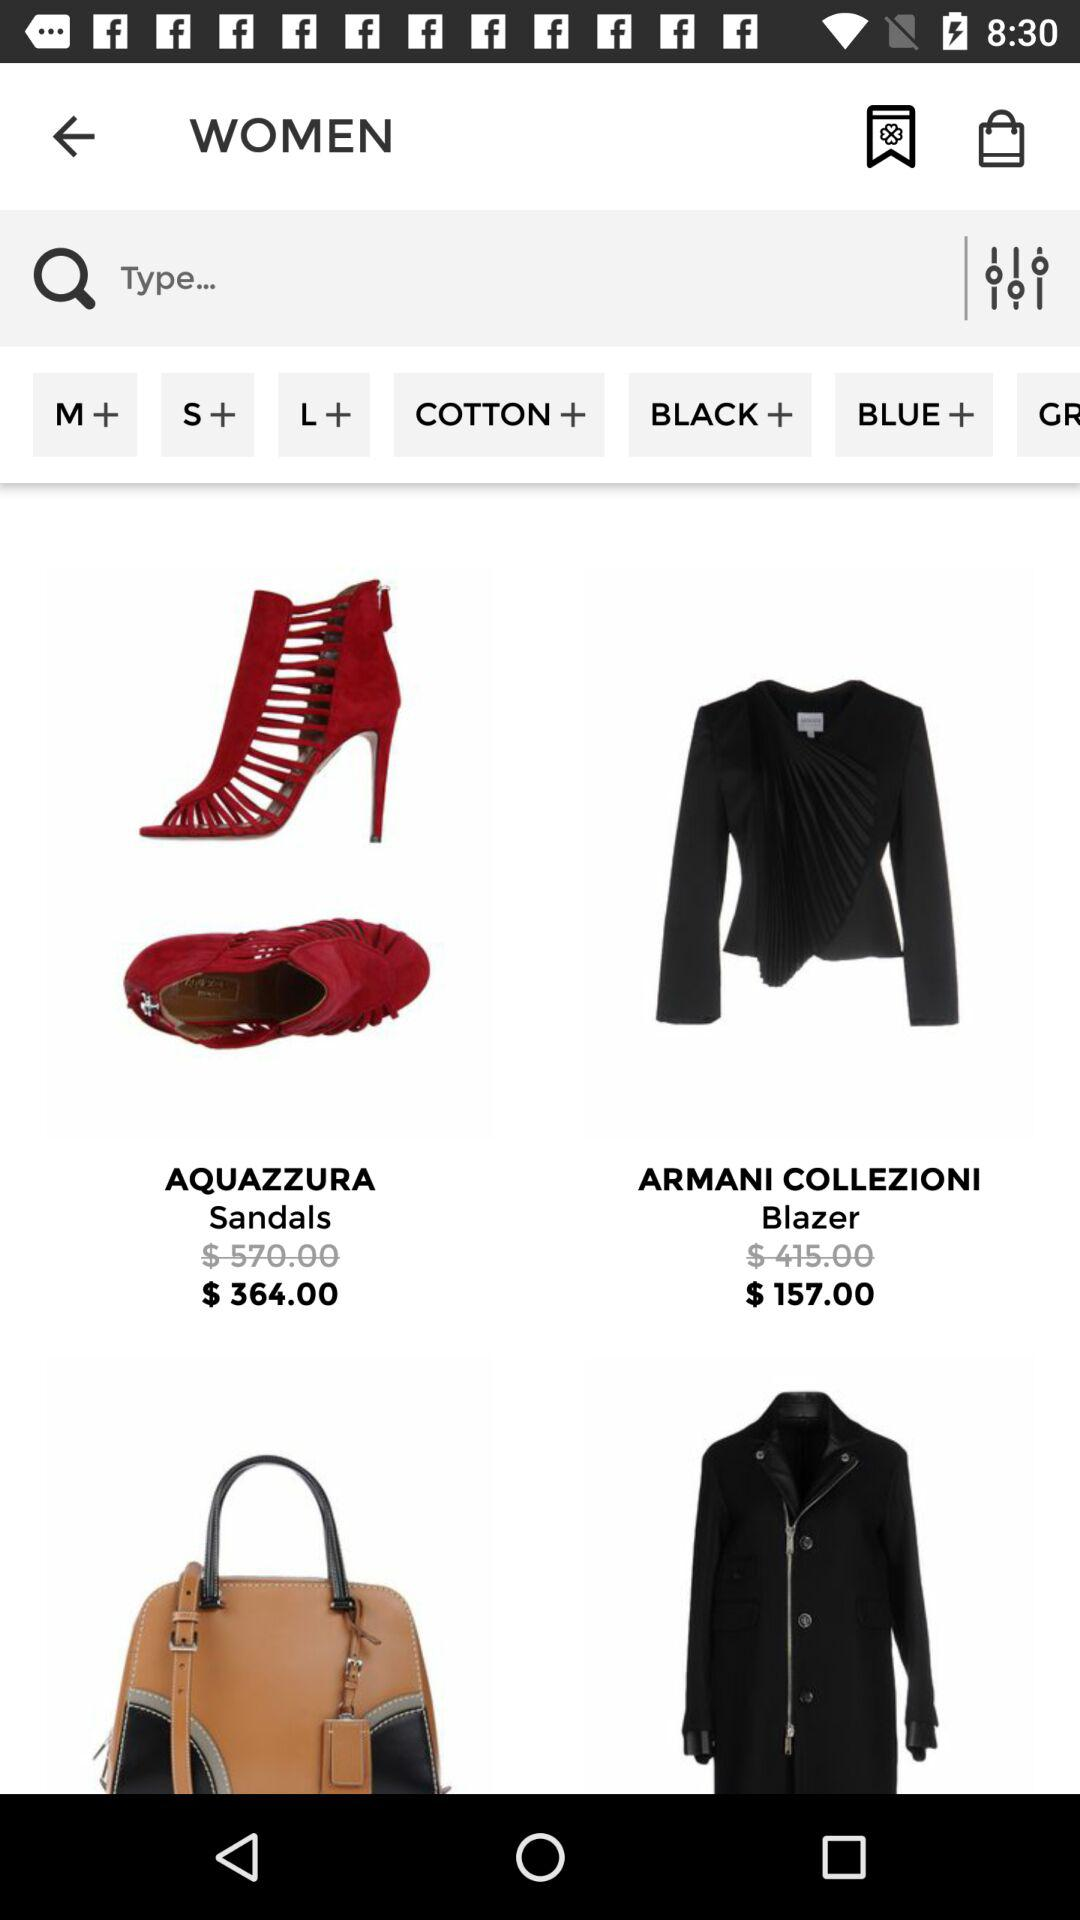How much is the Armani blazer in rupees?
When the provided information is insufficient, respond with <no answer>. <no answer> 